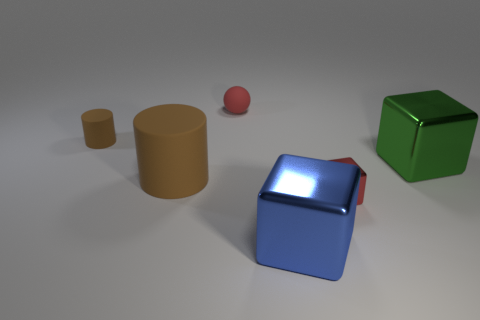How many things are either big brown things or tiny objects that are in front of the big green block?
Ensure brevity in your answer.  2. Are there more large green objects than big green rubber objects?
Ensure brevity in your answer.  Yes. What size is the metal object that is the same color as the sphere?
Provide a succinct answer. Small. Are there any large blue things made of the same material as the green block?
Make the answer very short. Yes. The thing that is to the left of the red rubber object and behind the green block has what shape?
Provide a succinct answer. Cylinder. What number of other things are there of the same shape as the tiny red metal object?
Offer a terse response. 2. The matte ball has what size?
Provide a short and direct response. Small. How many things are either large green spheres or red rubber objects?
Offer a very short reply. 1. There is a brown object that is behind the large green metal thing; how big is it?
Keep it short and to the point. Small. Is there anything else that has the same size as the red metal thing?
Your answer should be compact. Yes. 